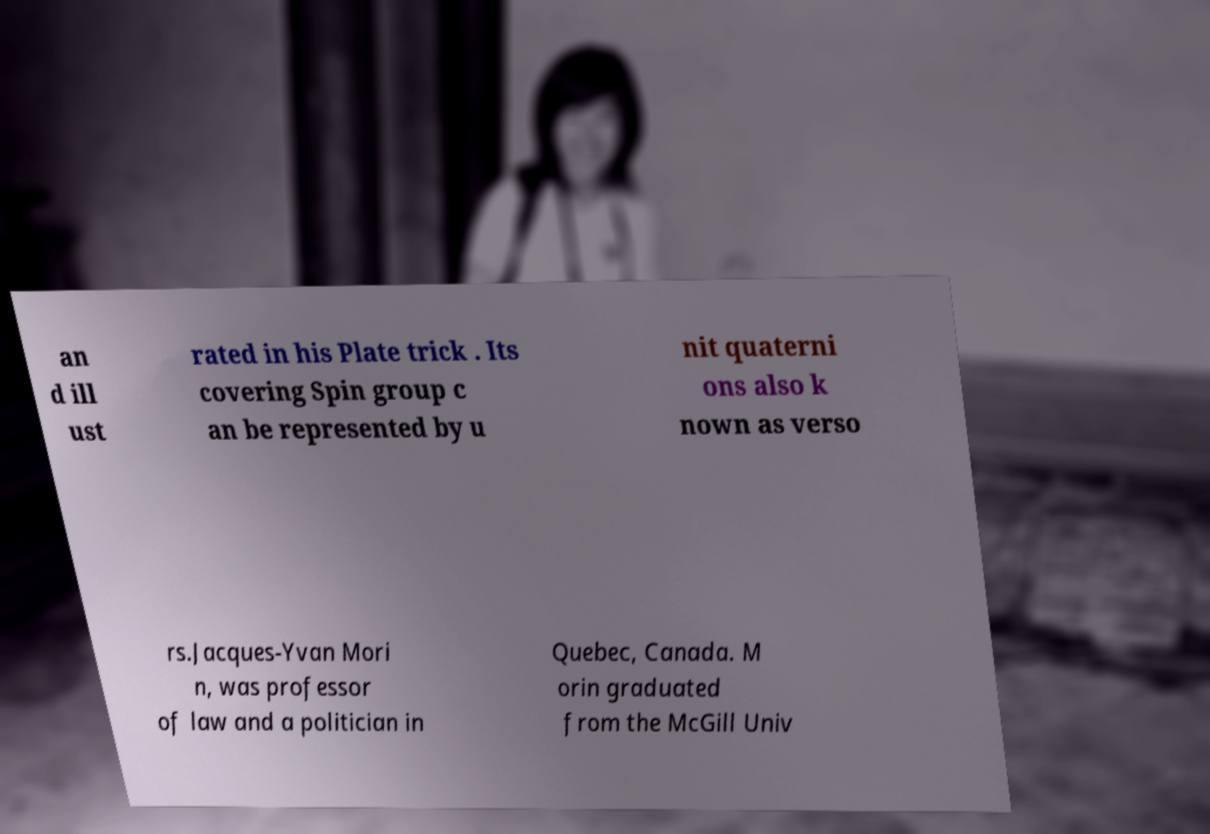I need the written content from this picture converted into text. Can you do that? an d ill ust rated in his Plate trick . Its covering Spin group c an be represented by u nit quaterni ons also k nown as verso rs.Jacques-Yvan Mori n, was professor of law and a politician in Quebec, Canada. M orin graduated from the McGill Univ 